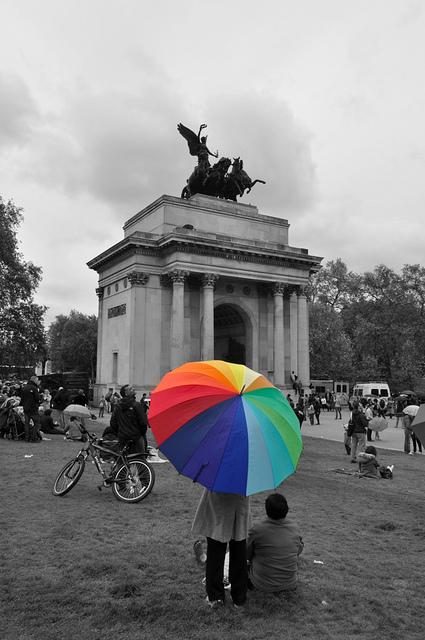How many umbrellas are in the picture?
Give a very brief answer. 1. How many colors is the umbrella?
Give a very brief answer. 16. What is the name of the large monument in this picture?
Keep it brief. Paul revere. What object did the photographer want to draw the viewer's eye to?
Give a very brief answer. Umbrella. 